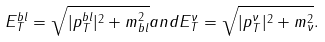<formula> <loc_0><loc_0><loc_500><loc_500>E ^ { b l } _ { T } = \sqrt { | p _ { T } ^ { b l } | ^ { 2 } + m ^ { 2 } _ { b l } } a n d E ^ { \nu } _ { T } = \sqrt { | p ^ { \nu } _ { T } | ^ { 2 } + m ^ { 2 } _ { \nu } } .</formula> 